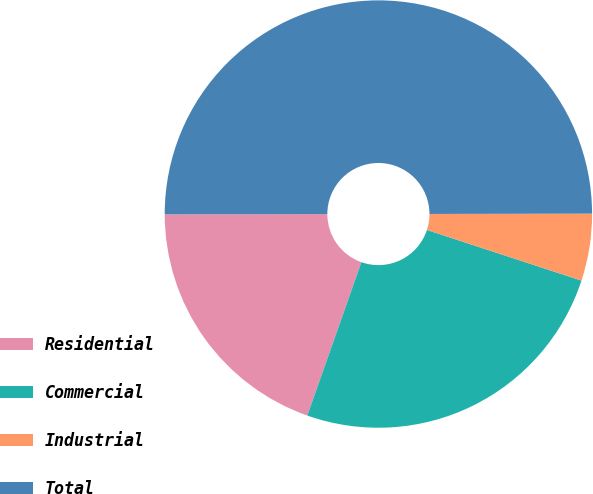Convert chart to OTSL. <chart><loc_0><loc_0><loc_500><loc_500><pie_chart><fcel>Residential<fcel>Commercial<fcel>Industrial<fcel>Total<nl><fcel>19.58%<fcel>25.36%<fcel>5.07%<fcel>50.0%<nl></chart> 